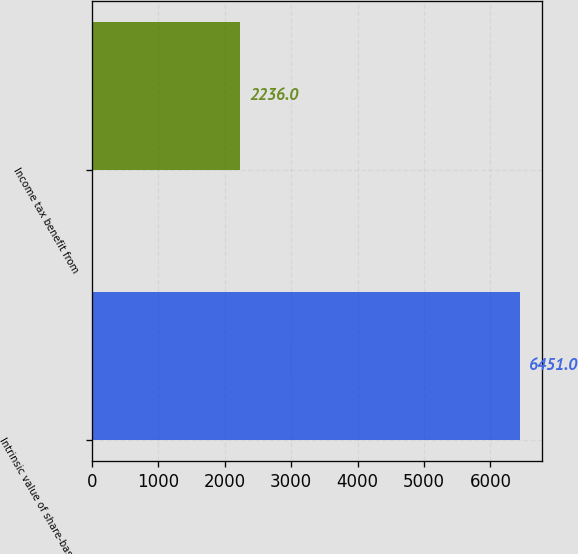<chart> <loc_0><loc_0><loc_500><loc_500><bar_chart><fcel>Intrinsic value of share-based<fcel>Income tax benefit from<nl><fcel>6451<fcel>2236<nl></chart> 